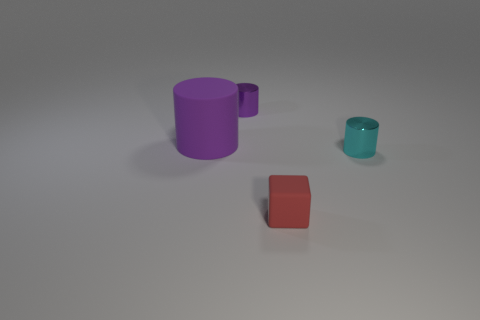What is the material of the big thing that is the same shape as the small cyan shiny object?
Give a very brief answer. Rubber. There is a object that is both behind the tiny rubber block and in front of the purple matte cylinder; what shape is it?
Your answer should be very brief. Cylinder. There is a purple object that is behind the cylinder on the left side of the tiny cylinder that is left of the small red matte block; what is it made of?
Make the answer very short. Metal. What size is the shiny cylinder that is the same color as the big object?
Make the answer very short. Small. What is the material of the small purple cylinder?
Offer a terse response. Metal. Does the big cylinder have the same material as the small cylinder that is right of the tiny red matte object?
Your answer should be very brief. No. The object that is on the left side of the object that is behind the large purple cylinder is what color?
Keep it short and to the point. Purple. There is a cylinder that is in front of the small purple shiny object and on the left side of the tiny red cube; what size is it?
Keep it short and to the point. Large. How many other objects are there of the same shape as the large matte thing?
Keep it short and to the point. 2. Do the cyan metal object and the rubber object on the left side of the small purple metallic cylinder have the same shape?
Your answer should be very brief. Yes. 